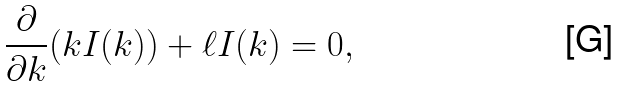<formula> <loc_0><loc_0><loc_500><loc_500>\frac { \partial } { \partial k } ( k I ( k ) ) + \ell I ( k ) = 0 ,</formula> 